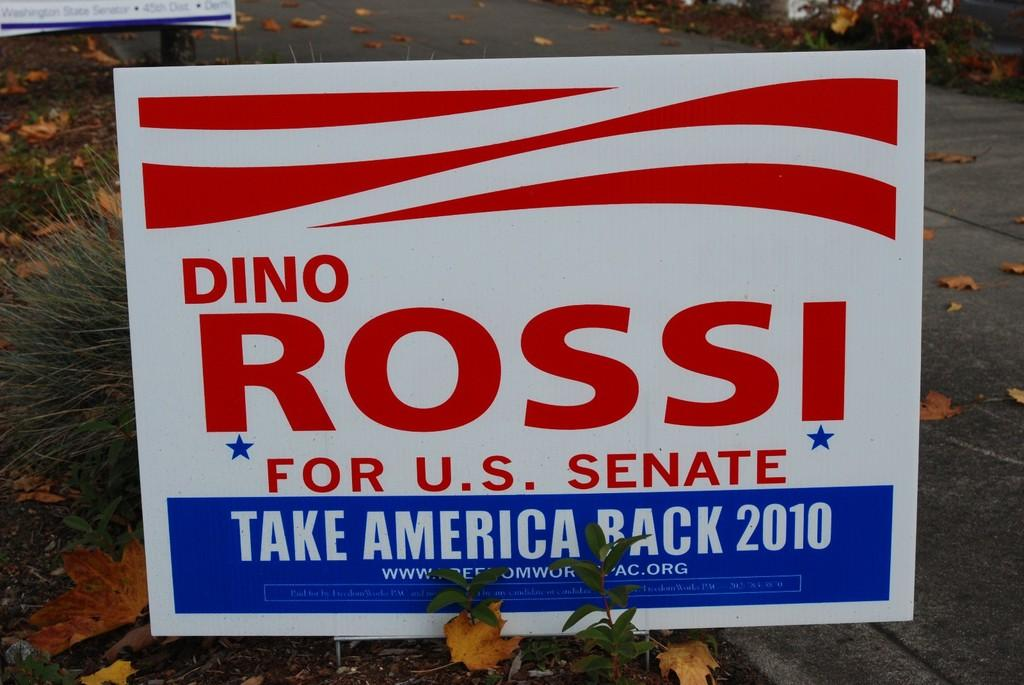<image>
Render a clear and concise summary of the photo. A political sign for Dino Rossi has blue stars under his name. 